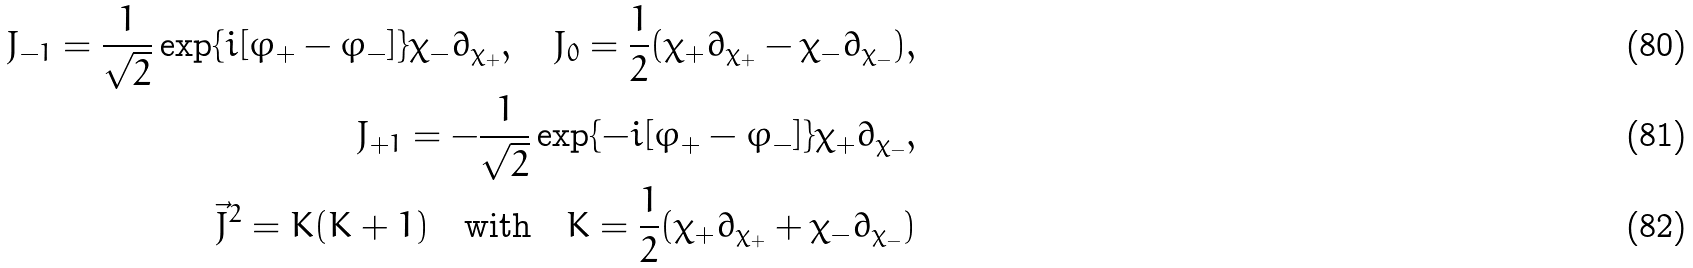<formula> <loc_0><loc_0><loc_500><loc_500>J _ { - 1 } = \frac { 1 } { \sqrt { 2 } } \exp \{ i [ \varphi _ { + } - \varphi _ { - } ] \} \chi _ { - } \partial _ { \chi _ { + } } , \quad J _ { 0 } = \frac { 1 } { 2 } ( \chi _ { + } \partial _ { \chi _ { + } } - \chi _ { - } \partial _ { \chi _ { - } } ) , \\ J _ { + 1 } = - \frac { 1 } { \sqrt { 2 } } \exp \{ - i [ \varphi _ { + } - \varphi _ { - } ] \} \chi _ { + } \partial _ { \chi _ { - } } , \\ \vec { J } ^ { 2 } = K ( K + 1 ) \quad \text {with} \quad K = \frac { 1 } { 2 } ( \chi _ { + } \partial _ { \chi _ { + } } + \chi _ { - } \partial _ { \chi _ { - } } )</formula> 